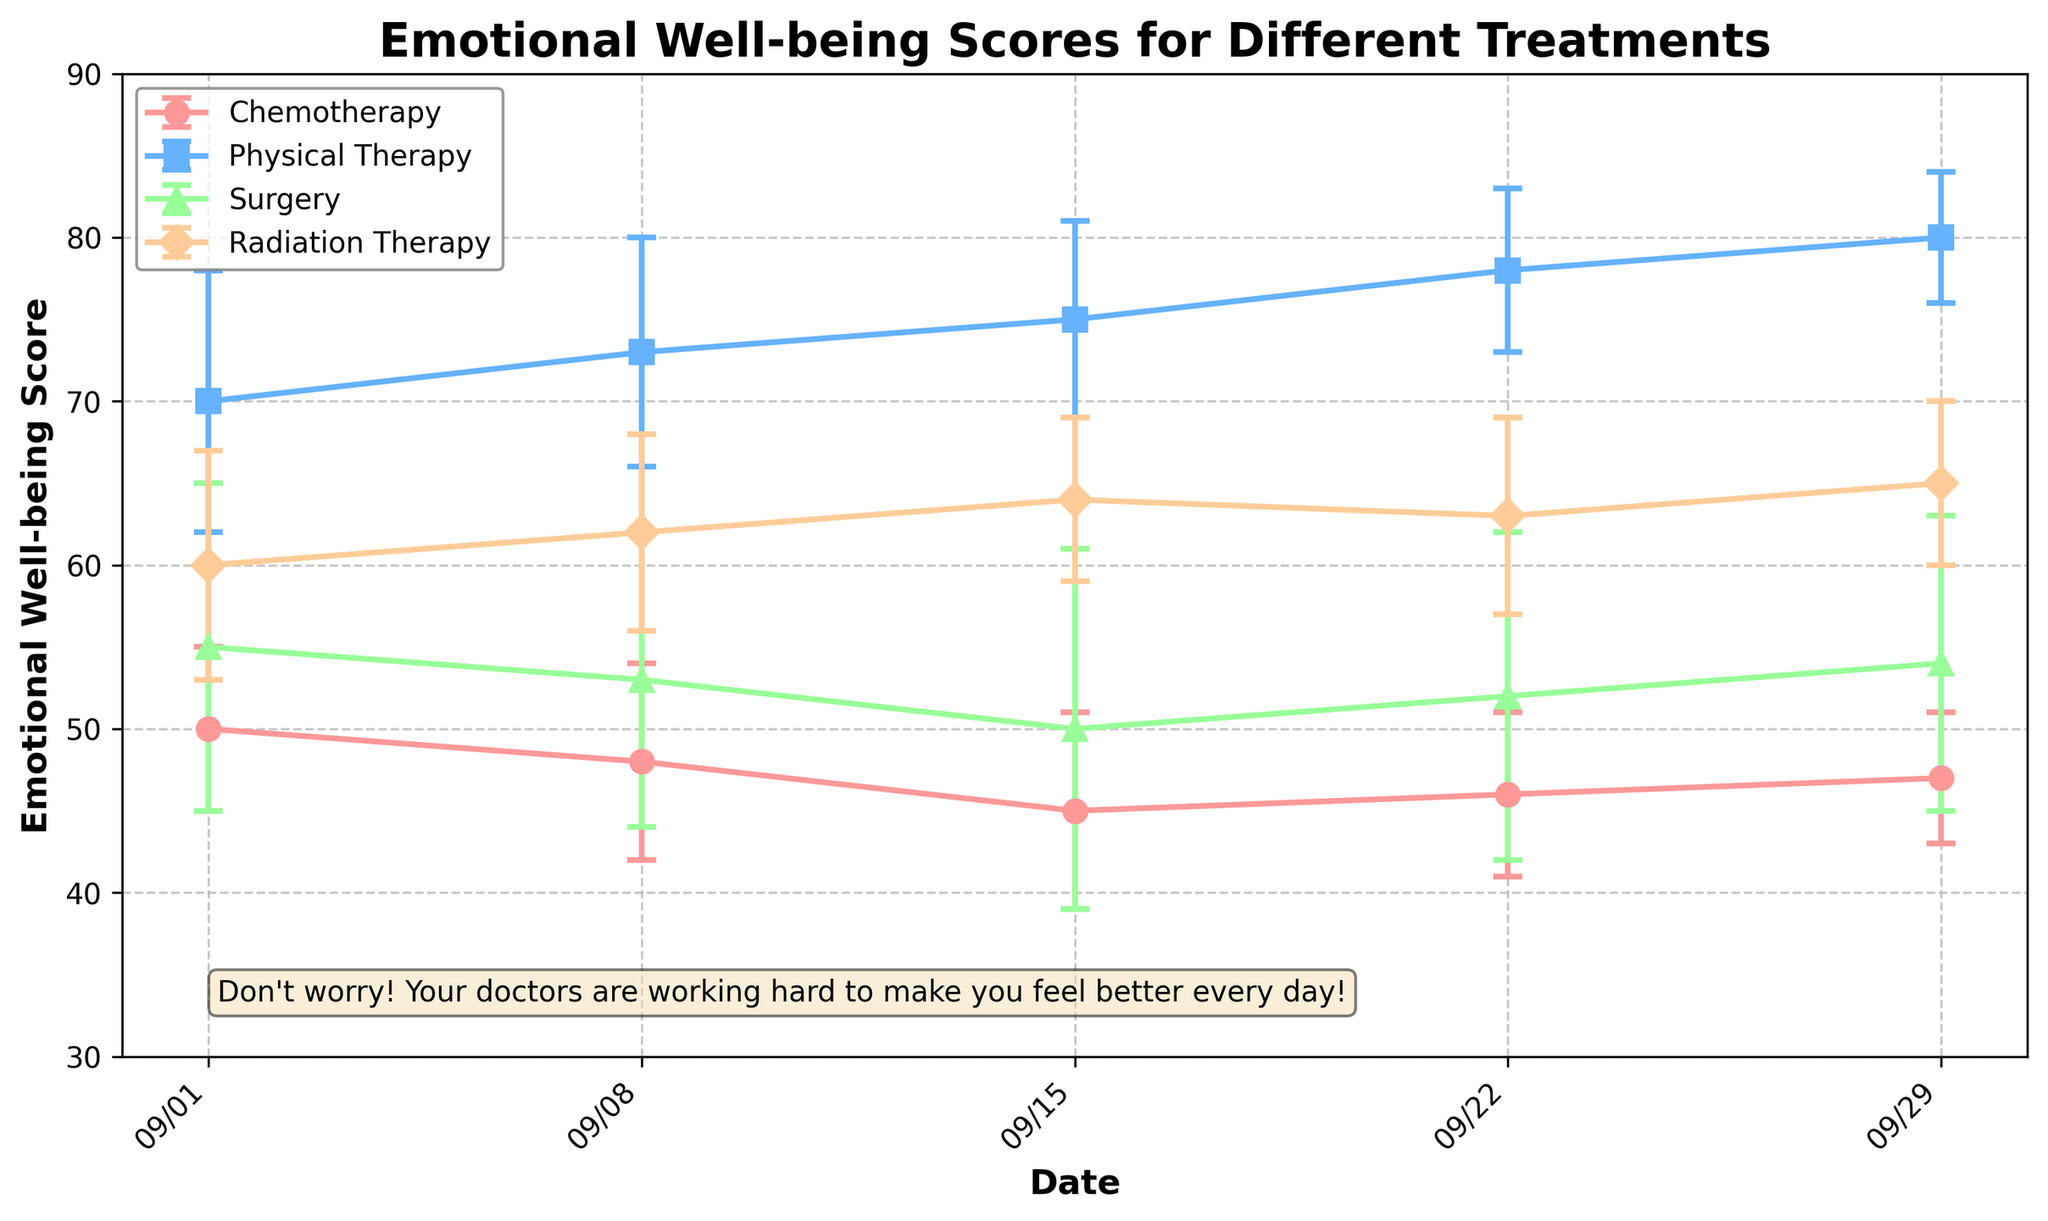What is the title of the plot? Look at the top of the plot. The text at the top is the title.
Answer: Emotional Well-being Scores for Different Treatments What is the date range shown on the x-axis? Check the first and last dates labeled on the x-axis.
Answer: 09/01 to 09/29 Which treatment type showed the highest mean emotional well-being score at the end of the month? Look at the data points on 09/29 and compare their values for each treatment type.
Answer: Physical Therapy How much did the score for Chemotherapy change from the first to the last date? Find the score for Chemotherapy on 09/01 and 09/29, then subtract the 09/01 value from the 09/29 value.
Answer: -3 Between Radiation Therapy and Surgery, which treatment had more variation in scores throughout the month? Look at the standard deviation (the length of the error bars) for both treatments over all dates.
Answer: Surgery Which treatment type had the smallest standard deviation in their mean scores on 09/29? Look at the lengths of the error bars on 09/29 and compare them.
Answer: Physical Therapy For which dates did Physical Therapy have a mean score above 75? Identify the dates where the mean score for Physical Therapy is above 75.
Answer: 09/15, 09/22, 09/29 On which date did Radiation Therapy have its highest score? Look for the highest point of Radiation Therapy's line in the plot.
Answer: 09/29 Did any treatment type show a consistent increase in mean emotional well-being scores throughout the month? Check each treatment's line on the plot to see if any line is consistently rising from left to right.
Answer: Physical Therapy Is the emotional well-being score on 09/08 for Surgery higher or lower than the score for Chemotherapy on the same date? Compare the points for Surgery and Chemotherapy on 09/08.
Answer: Higher 